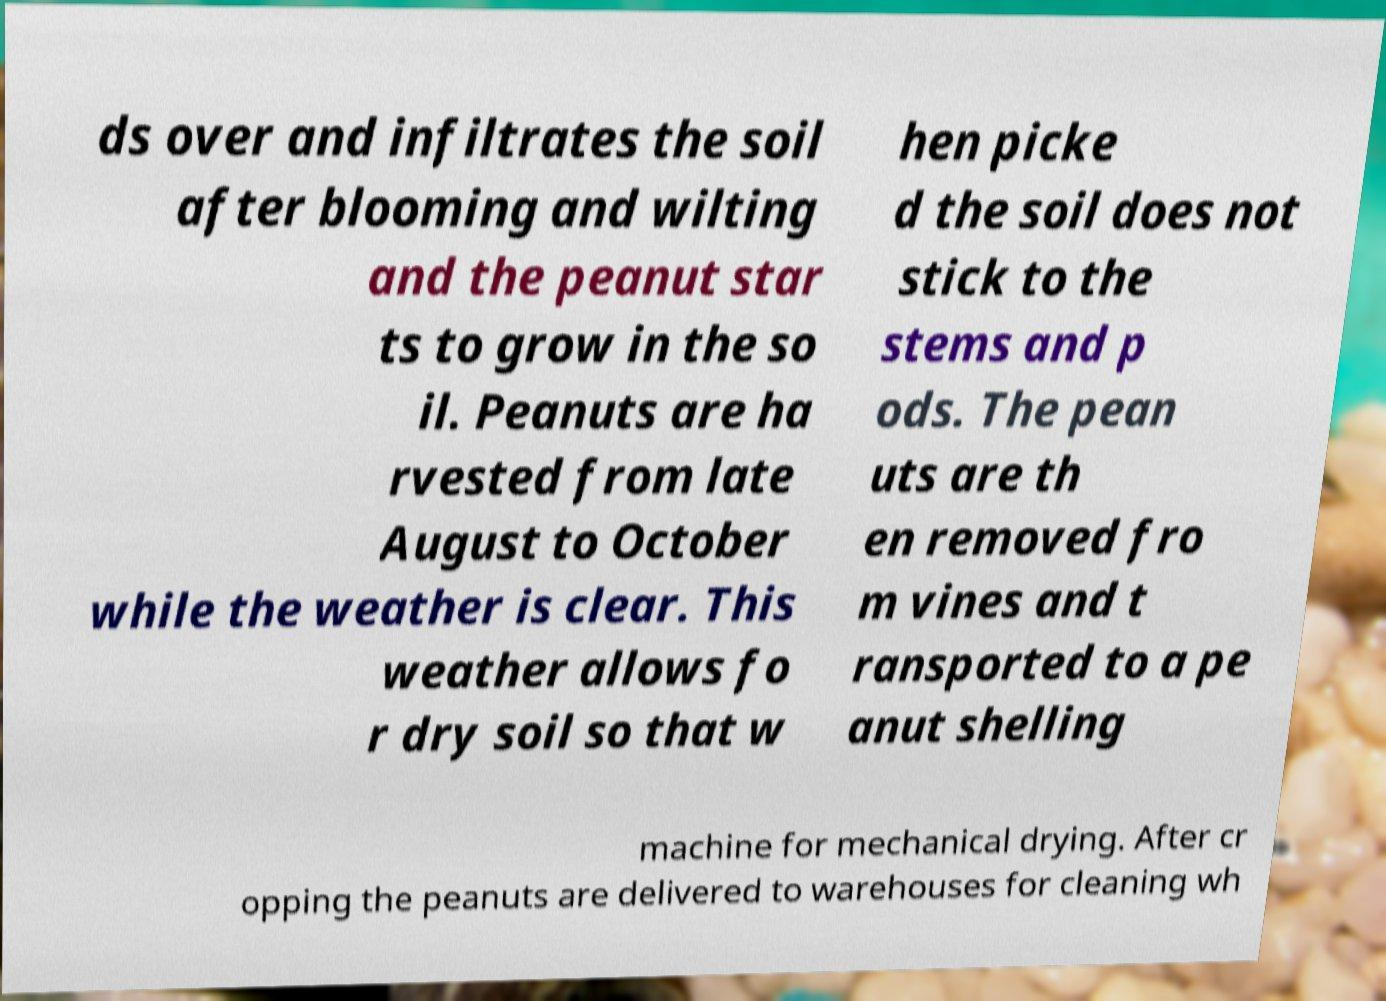Can you read and provide the text displayed in the image?This photo seems to have some interesting text. Can you extract and type it out for me? ds over and infiltrates the soil after blooming and wilting and the peanut star ts to grow in the so il. Peanuts are ha rvested from late August to October while the weather is clear. This weather allows fo r dry soil so that w hen picke d the soil does not stick to the stems and p ods. The pean uts are th en removed fro m vines and t ransported to a pe anut shelling machine for mechanical drying. After cr opping the peanuts are delivered to warehouses for cleaning wh 